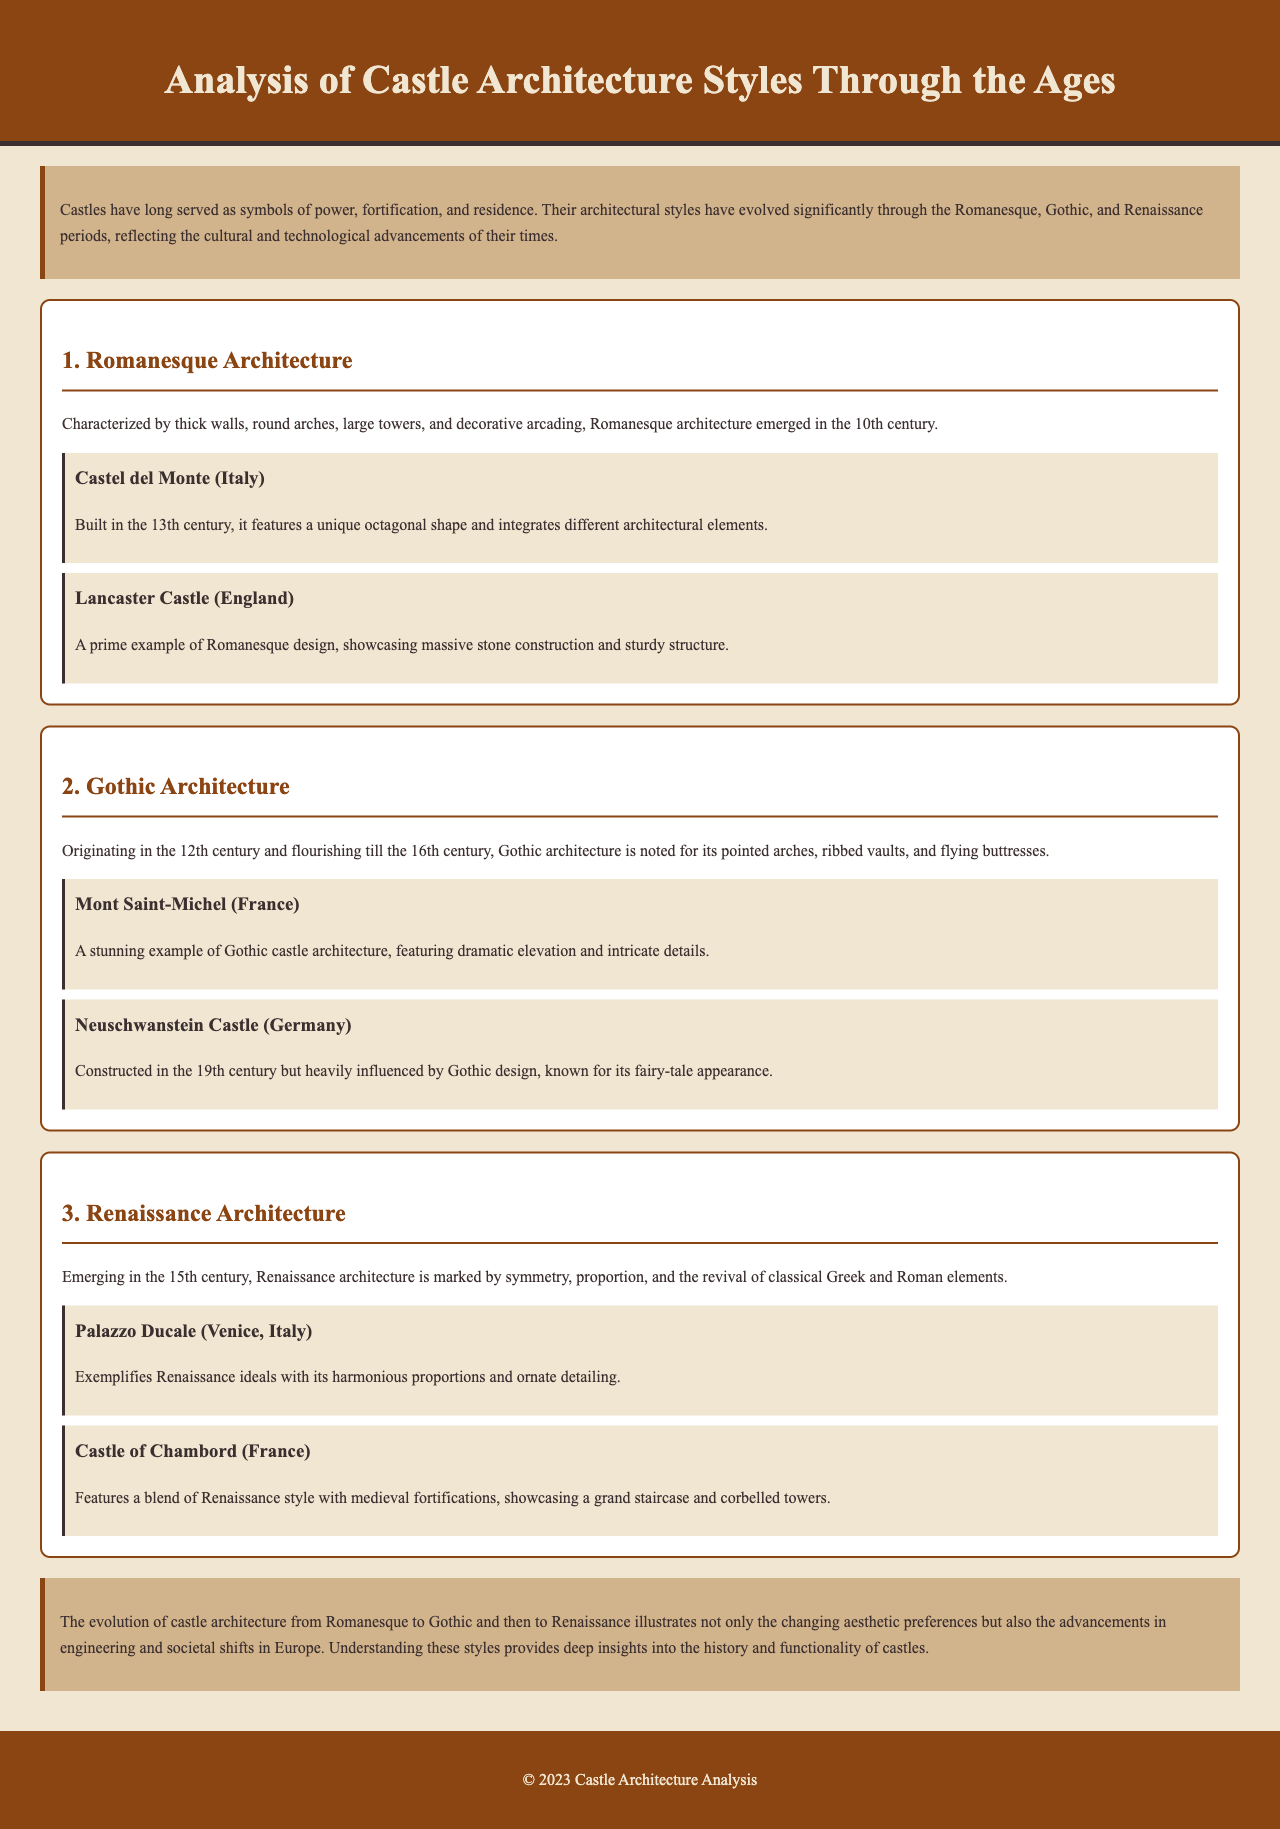What are the three architectural styles discussed in the report? The report discusses Romanesque, Gothic, and Renaissance architectural styles.
Answer: Romanesque, Gothic, Renaissance When did Gothic architecture originate? The section on Gothic architecture states that it originated in the 12th century.
Answer: 12th century Which castle is a prime example of Romanesque design? Lancaster Castle is mentioned as a prime example of Romanesque design in the document.
Answer: Lancaster Castle What feature is characteristic of Renaissance architecture? The report states that Renaissance architecture is marked by symmetry, proportion, and the revival of classical elements.
Answer: Symmetry How many examples of castles are provided for each architectural style? The report provides two examples of castles for each of the three architectural styles.
Answer: Two What is a notable feature of Mont Saint-Michel? Mont Saint-Michel is praised for its dramatic elevation and intricate details in the Gothic architecture section.
Answer: Dramatic elevation Which castle features a blend of Renaissance style with medieval fortifications? The Castle of Chambord is specifically noted for its blend of Renaissance style with medieval fortifications.
Answer: Castle of Chambord In what century was Castel del Monte built? The document states that Castel del Monte was built in the 13th century.
Answer: 13th century What does the conclusion emphasize about the evolution of castle architecture? The conclusion emphasizes the changing aesthetic preferences and advancements in engineering and societal shifts.
Answer: Changing aesthetic preferences, advancements in engineering 